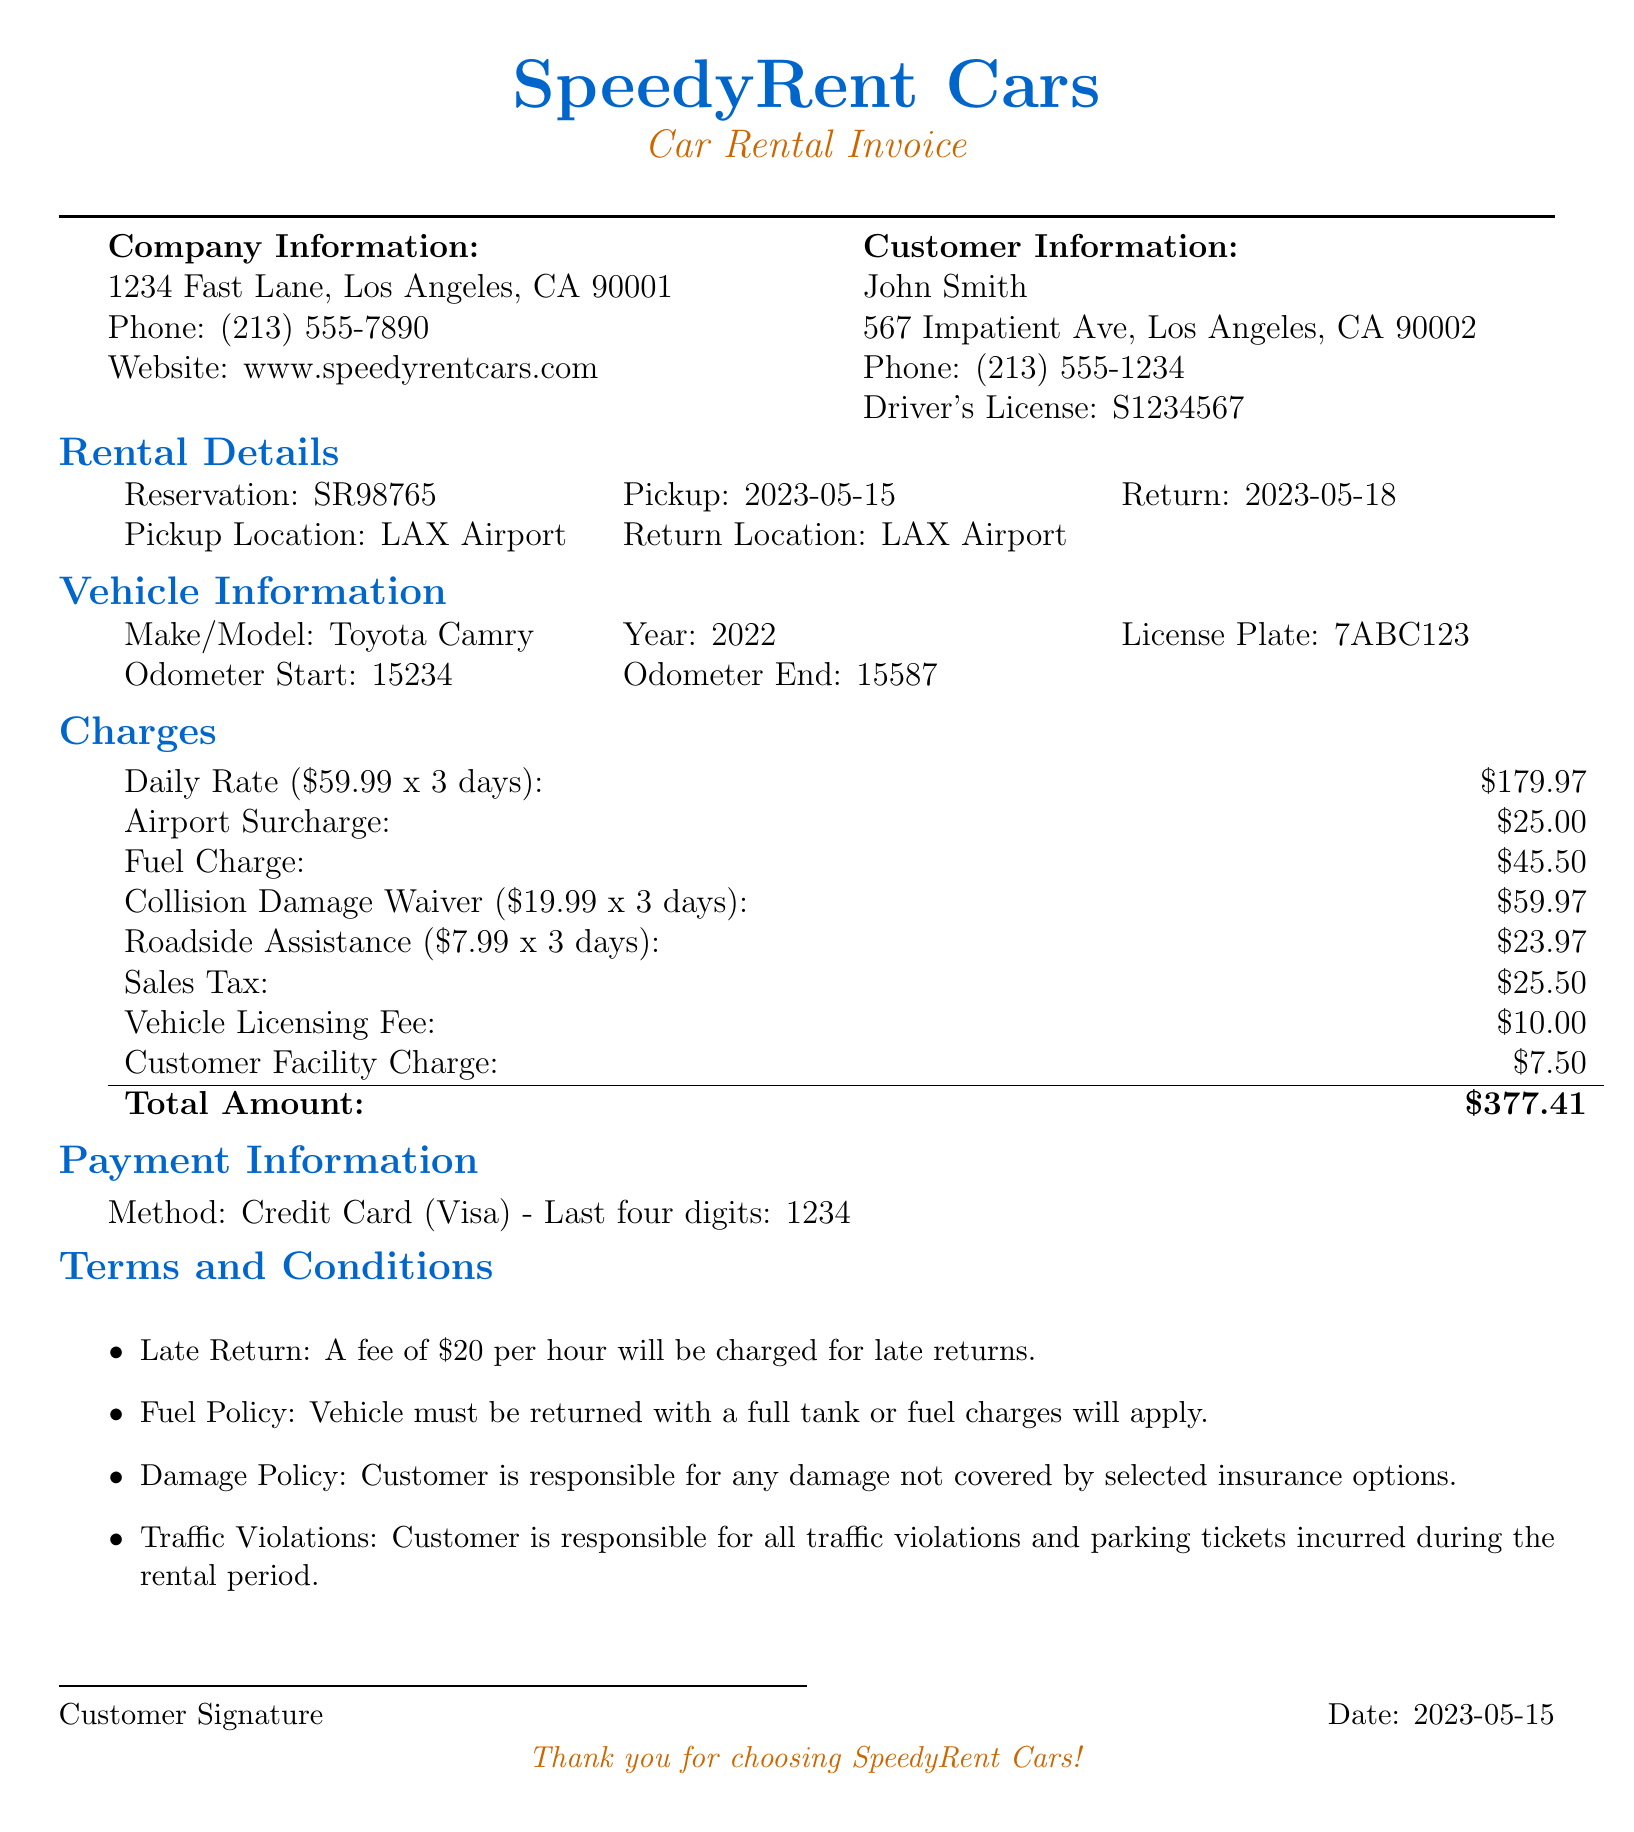What is the name of the rental company? The name of the rental company is listed in the document under company information.
Answer: SpeedyRent Cars What is the reservation number? The reservation number can be found in the rental details section of the document.
Answer: SR98765 When is the vehicle pickup date? The pickup date is specified in the rental details section of the document.
Answer: 2023-05-15 What is the total amount charged? The total amount charged is indicated at the end of the charges section in the document.
Answer: $377.41 How much is the daily rate for the vehicle? The daily rate can be found in the rental charges section of the document.
Answer: $59.99 Is personal accident insurance selected? Whether personal accident insurance is selected is mentioned under insurance options in the document.
Answer: No What fee applies for late returns? The late return policy states the fee per hour for late returns in the terms and conditions of the document.
Answer: $20 per hour What is the model of the rented vehicle? The model of the rented vehicle is specified in the vehicle information section of the document.
Answer: Camry What is included in the additional charges? Additional charges are itemized in the charges section of the document.
Answer: Airport Surcharge, Fuel Charge 